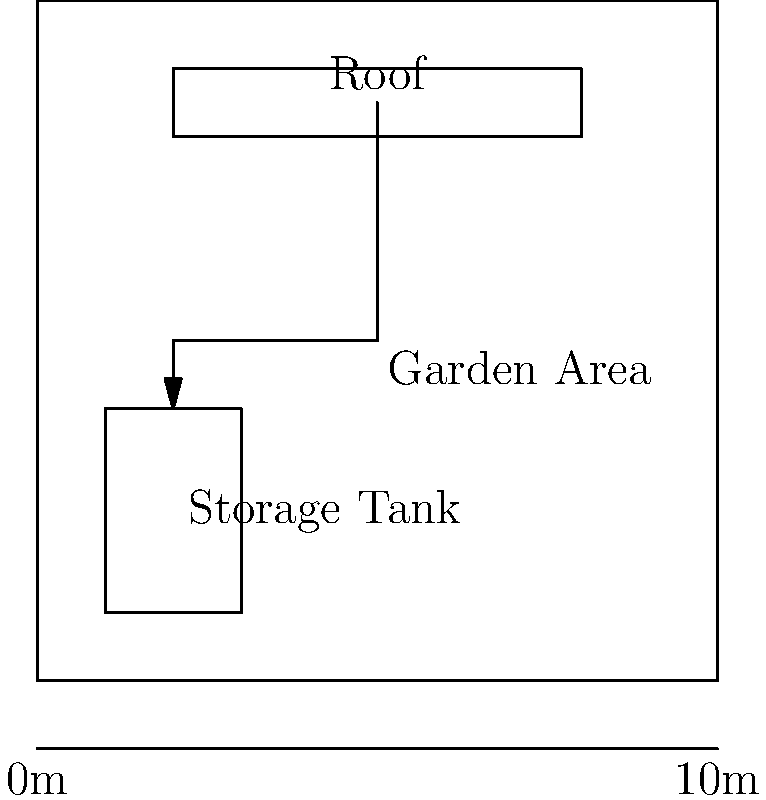For the eco-friendly rainwater harvesting system in your sculpture garden, you need to calculate the potential water collection volume. Given a roof area of 60 m² and an average annual rainfall of 800 mm, what is the maximum volume of water that can be collected in a year, assuming 80% efficiency due to losses? Express your answer in cubic meters (m³). To calculate the potential water collection volume, we'll follow these steps:

1. Convert the rainfall from millimeters to meters:
   800 mm = 0.8 m

2. Calculate the total volume of water falling on the roof:
   Volume = Roof Area × Rainfall
   $V = 60 \text{ m}^2 \times 0.8 \text{ m} = 48 \text{ m}^3$

3. Apply the efficiency factor to account for losses:
   Collectable Volume = Total Volume × Efficiency
   $V_{collectable} = 48 \text{ m}^3 \times 0.8 = 38.4 \text{ m}^3$

Therefore, the maximum volume of water that can be collected in a year is 38.4 m³.
Answer: 38.4 m³ 